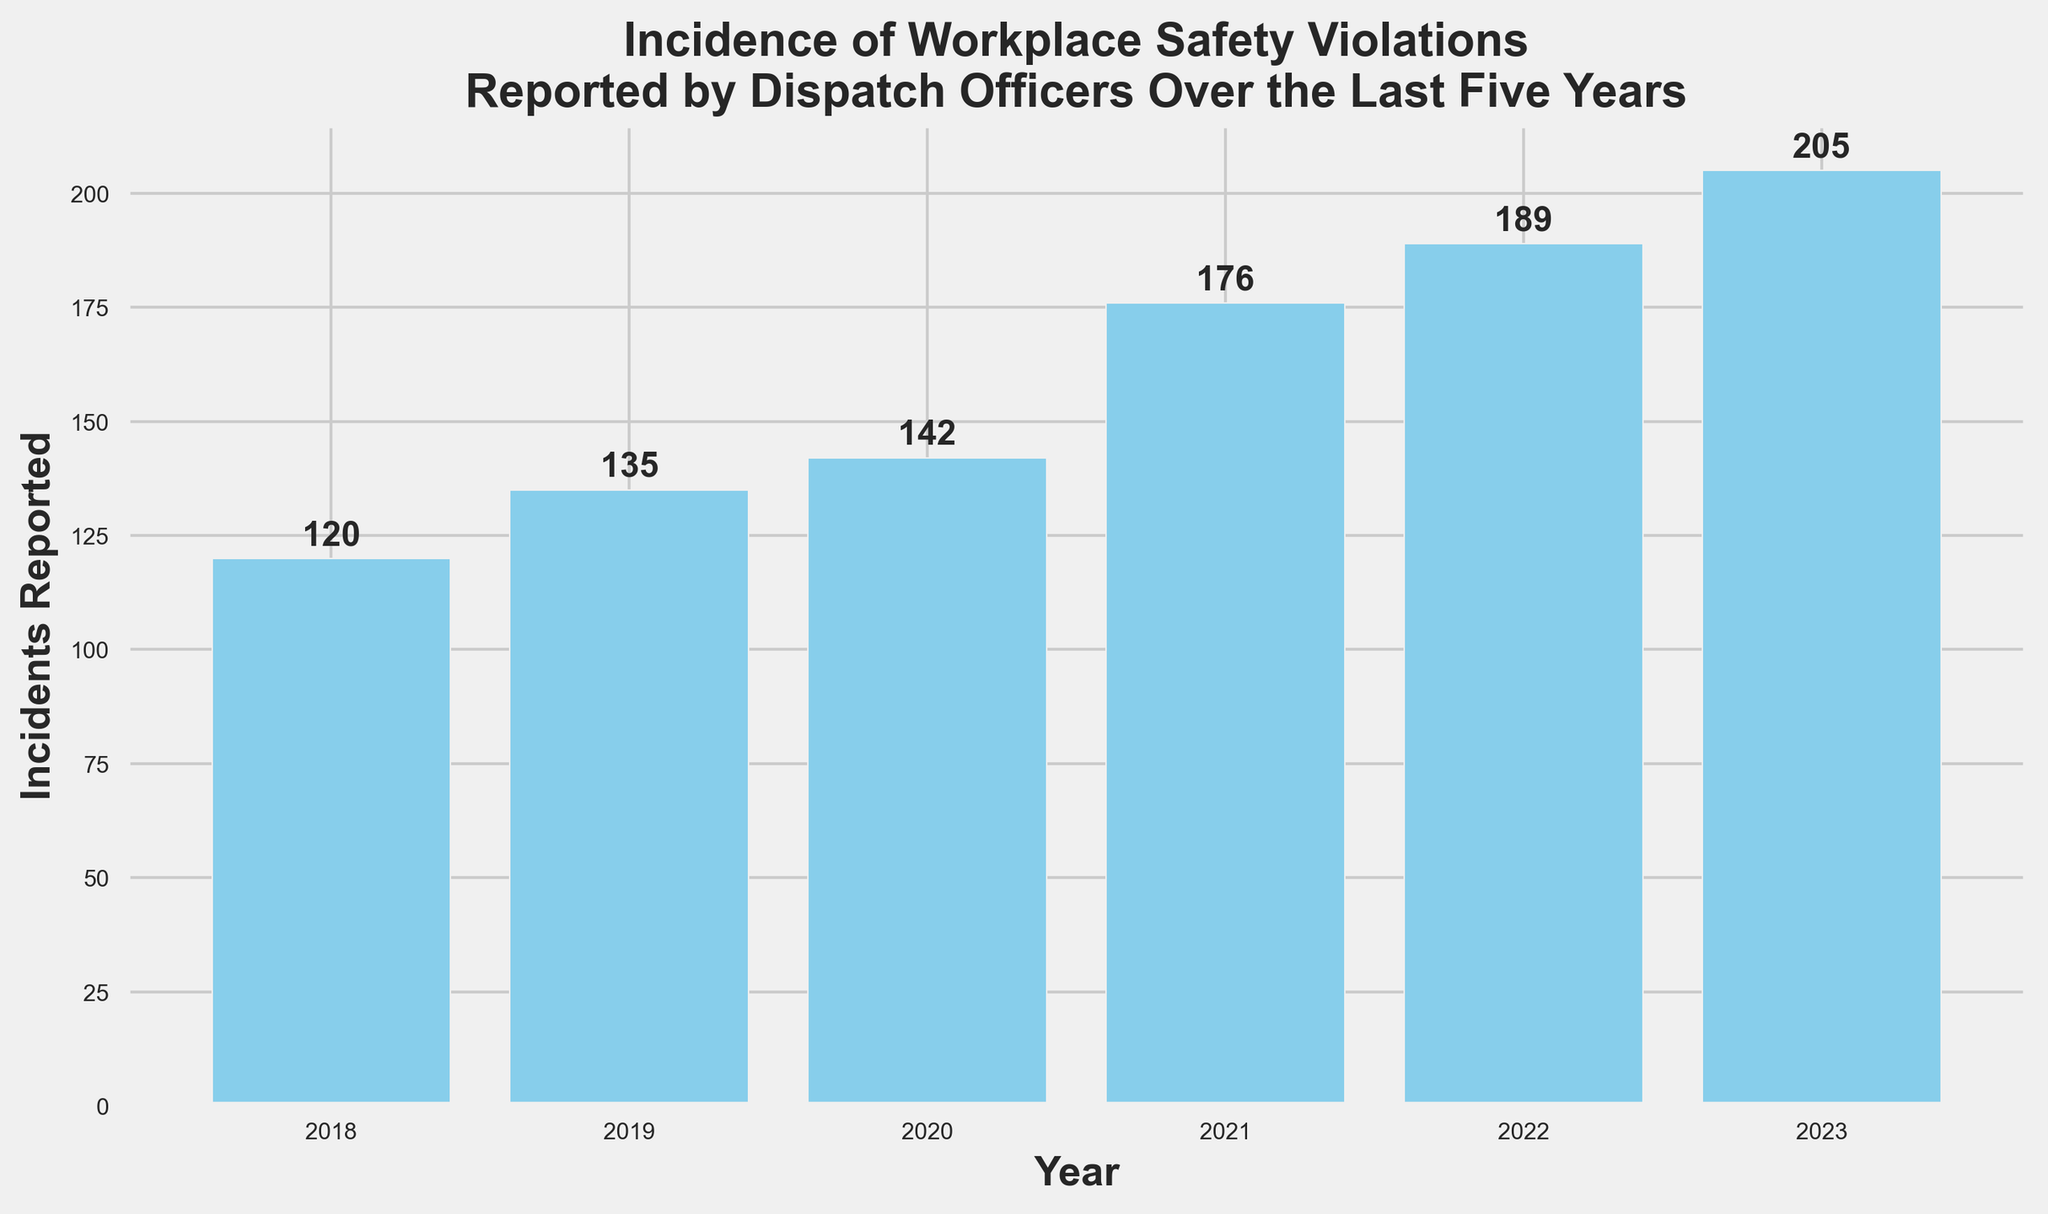What's the total number of incidents reported over the last five years? Add the number of incidents reported each year from 2018 to 2023: 120 + 135 + 142 + 176 + 189 + 205. This gives the total: 967
Answer: 967 Which year had the highest number of incidents reported? Look at the bar heights; the tallest bar represents the year with the most incidents. The year 2023 has the tallest bar with 205 incidents reported.
Answer: 2023 How much did the number of incidents reported increase from 2018 to 2023? Subtract the number of incidents reported in 2018 from the number in 2023: 205 - 120. The increase is 85 incidents.
Answer: 85 What’s the average number of incidents reported per year over the last five years? Calculate the total number of incidents reported (967) and divide by the number of years (6): 967 / 6 = 161.17
Answer: 161.17 Which year showed the largest single-year increase in incidents reported? Compare the difference in incidents reported between consecutive years: 
2019-2018: 135 - 120 = 15 
2020-2019: 142 - 135 = 7 
2021-2020: 176 - 142 = 34 
2022-2021: 189 - 176 = 13 
2023-2022: 205 - 189 = 16. The largest increase is from 2020 to 2021 with an increase of 34.
Answer: 2021 By how many incidents did the reports increase from 2021 to 2023? The number of incidents reported in 2021 was 176 and in 2023 was 205. Subtract 176 from 205: 205 - 176 = 29
Answer: 29 Which two consecutive years had the smallest change in the number of incidents reported? Calculate the difference between incidents reported each year: 
2019-2018: 15 
2020-2019: 7 
2021-2020: 34 
2022-2021: 13 
2023-2022: 16. The smallest change is between 2019 and 2020 with a difference of 7.
Answer: 2019 and 2020 What is the average number of incidents reported in the last three years of the recorded period? Sum the incidents reported in 2021, 2022, and 2023: 176 + 189 + 205 = 570. Then divide by 3: 570 / 3 = 190
Answer: 190 